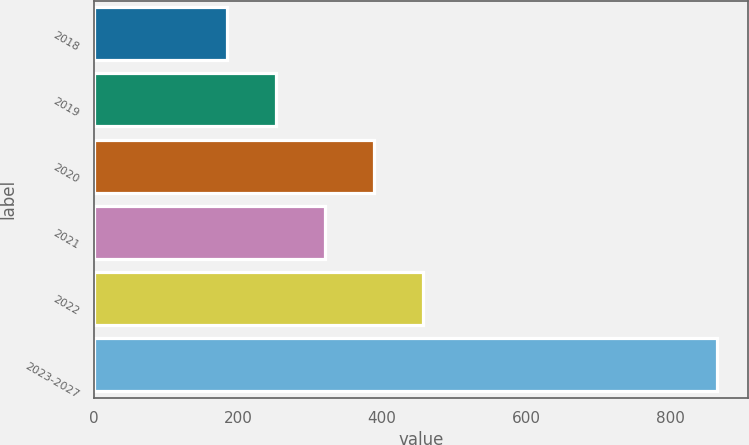Convert chart. <chart><loc_0><loc_0><loc_500><loc_500><bar_chart><fcel>2018<fcel>2019<fcel>2020<fcel>2021<fcel>2022<fcel>2023-2027<nl><fcel>185<fcel>253<fcel>389<fcel>321<fcel>457<fcel>865<nl></chart> 